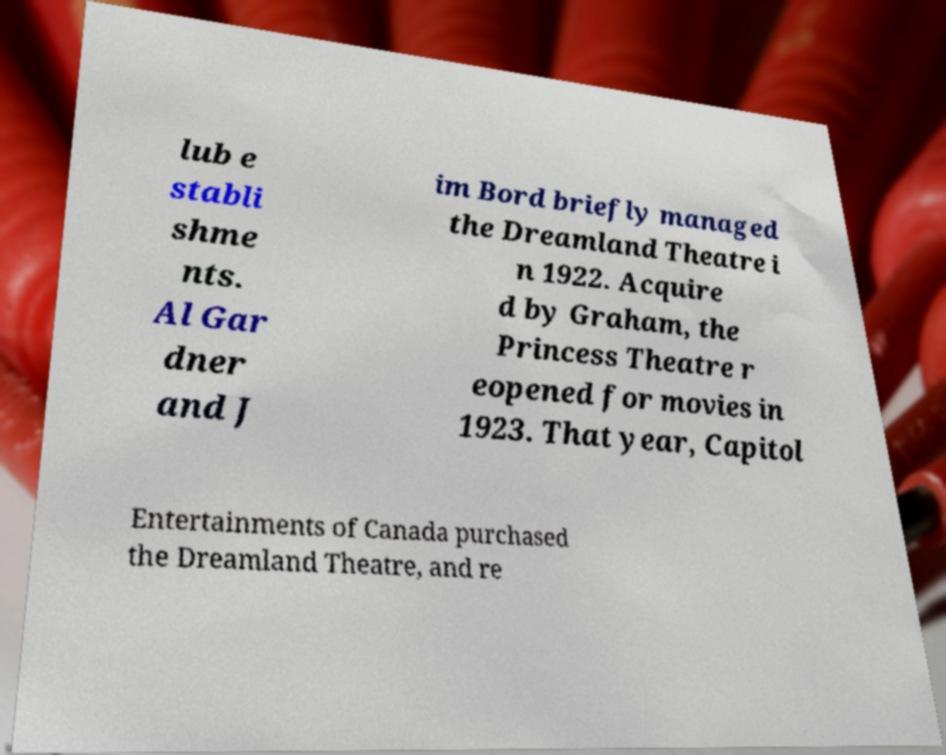For documentation purposes, I need the text within this image transcribed. Could you provide that? lub e stabli shme nts. Al Gar dner and J im Bord briefly managed the Dreamland Theatre i n 1922. Acquire d by Graham, the Princess Theatre r eopened for movies in 1923. That year, Capitol Entertainments of Canada purchased the Dreamland Theatre, and re 